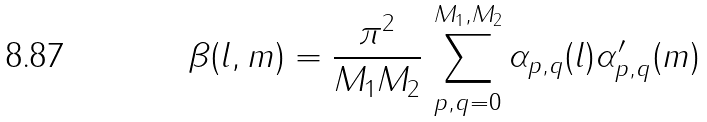<formula> <loc_0><loc_0><loc_500><loc_500>\beta ( l , m ) = \frac { \pi ^ { 2 } } { M _ { 1 } M _ { 2 } } \, \sum _ { p , q = 0 } ^ { M _ { 1 } , M _ { 2 } } \alpha _ { p , q } ( l ) \alpha ^ { \prime } _ { p , q } ( m )</formula> 